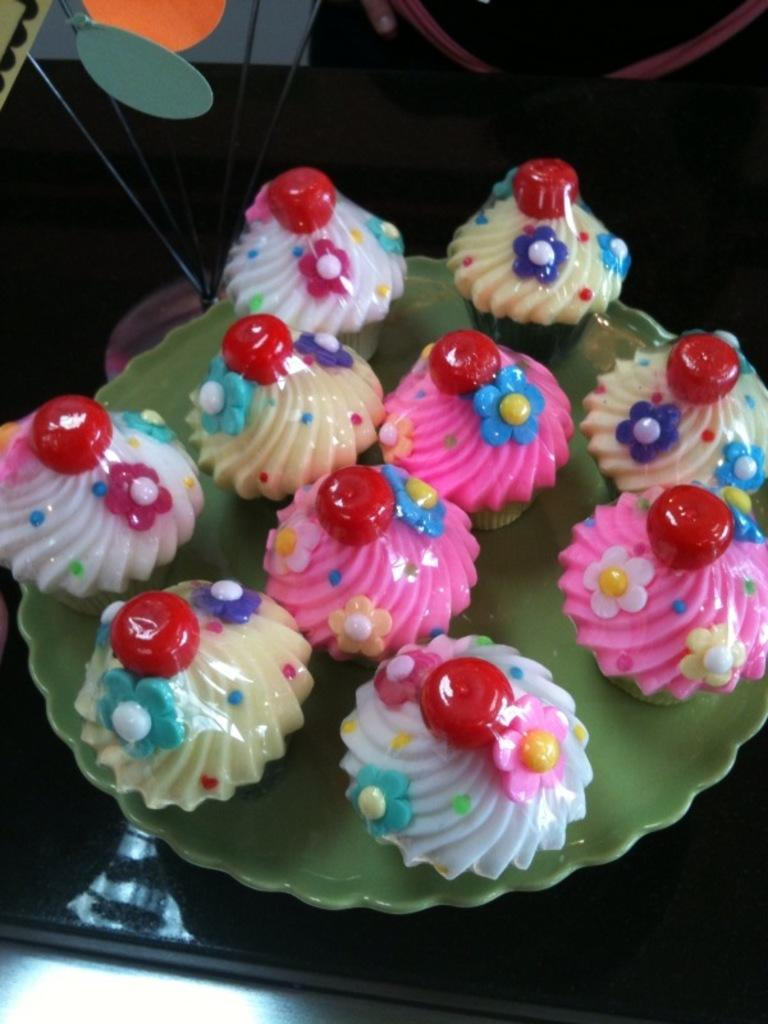What type of food is visible in the image? There are cupcakes in the image. How are the cupcakes arranged? The cupcakes are arranged on a green color plate. What can be seen in the background of the image? There are other objects in the background of the image. What is the color of the background in the image? The background of the image is dark in color. What type of crook is visible in the image? There is no crook present in the image. What is the weight of the dinner plate in the image? There is no dinner plate present in the image, and therefore no weight can be determined. 